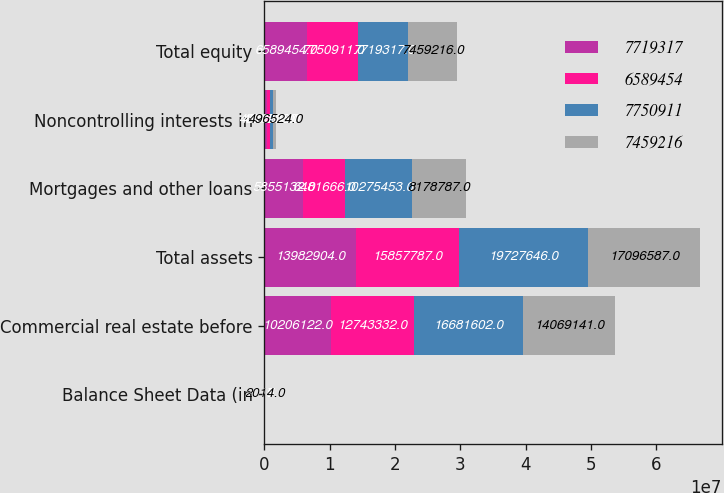Convert chart to OTSL. <chart><loc_0><loc_0><loc_500><loc_500><stacked_bar_chart><ecel><fcel>Balance Sheet Data (in<fcel>Commercial real estate before<fcel>Total assets<fcel>Mortgages and other loans<fcel>Noncontrolling interests in<fcel>Total equity<nl><fcel>7.71932e+06<fcel>2017<fcel>1.02061e+07<fcel>1.39829e+07<fcel>5.85513e+06<fcel>461954<fcel>6.58945e+06<nl><fcel>6.58945e+06<fcel>2016<fcel>1.27433e+07<fcel>1.58578e+07<fcel>6.48167e+06<fcel>473882<fcel>7.75091e+06<nl><fcel>7.75091e+06<fcel>2015<fcel>1.66816e+07<fcel>1.97276e+07<fcel>1.02755e+07<fcel>424206<fcel>7.71932e+06<nl><fcel>7.45922e+06<fcel>2014<fcel>1.40691e+07<fcel>1.70966e+07<fcel>8.17879e+06<fcel>496524<fcel>7.45922e+06<nl></chart> 